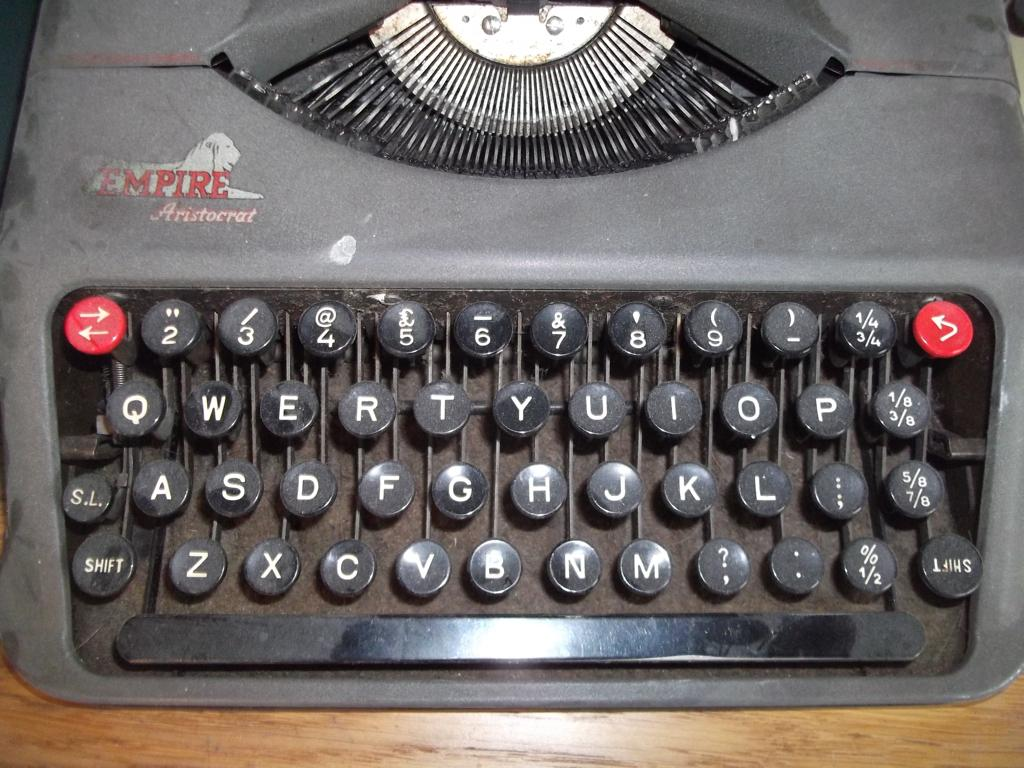What is the main object in the image? There is a typewriter in the image. What is the typewriter placed on? The typewriter is on a wooden table. How many turkeys are sitting on the typewriter in the image? There are no turkeys present in the image; it only features a typewriter on a wooden table. What type of cap is the typewriter wearing in the image? Typewriters do not wear caps, as they are inanimate objects. 